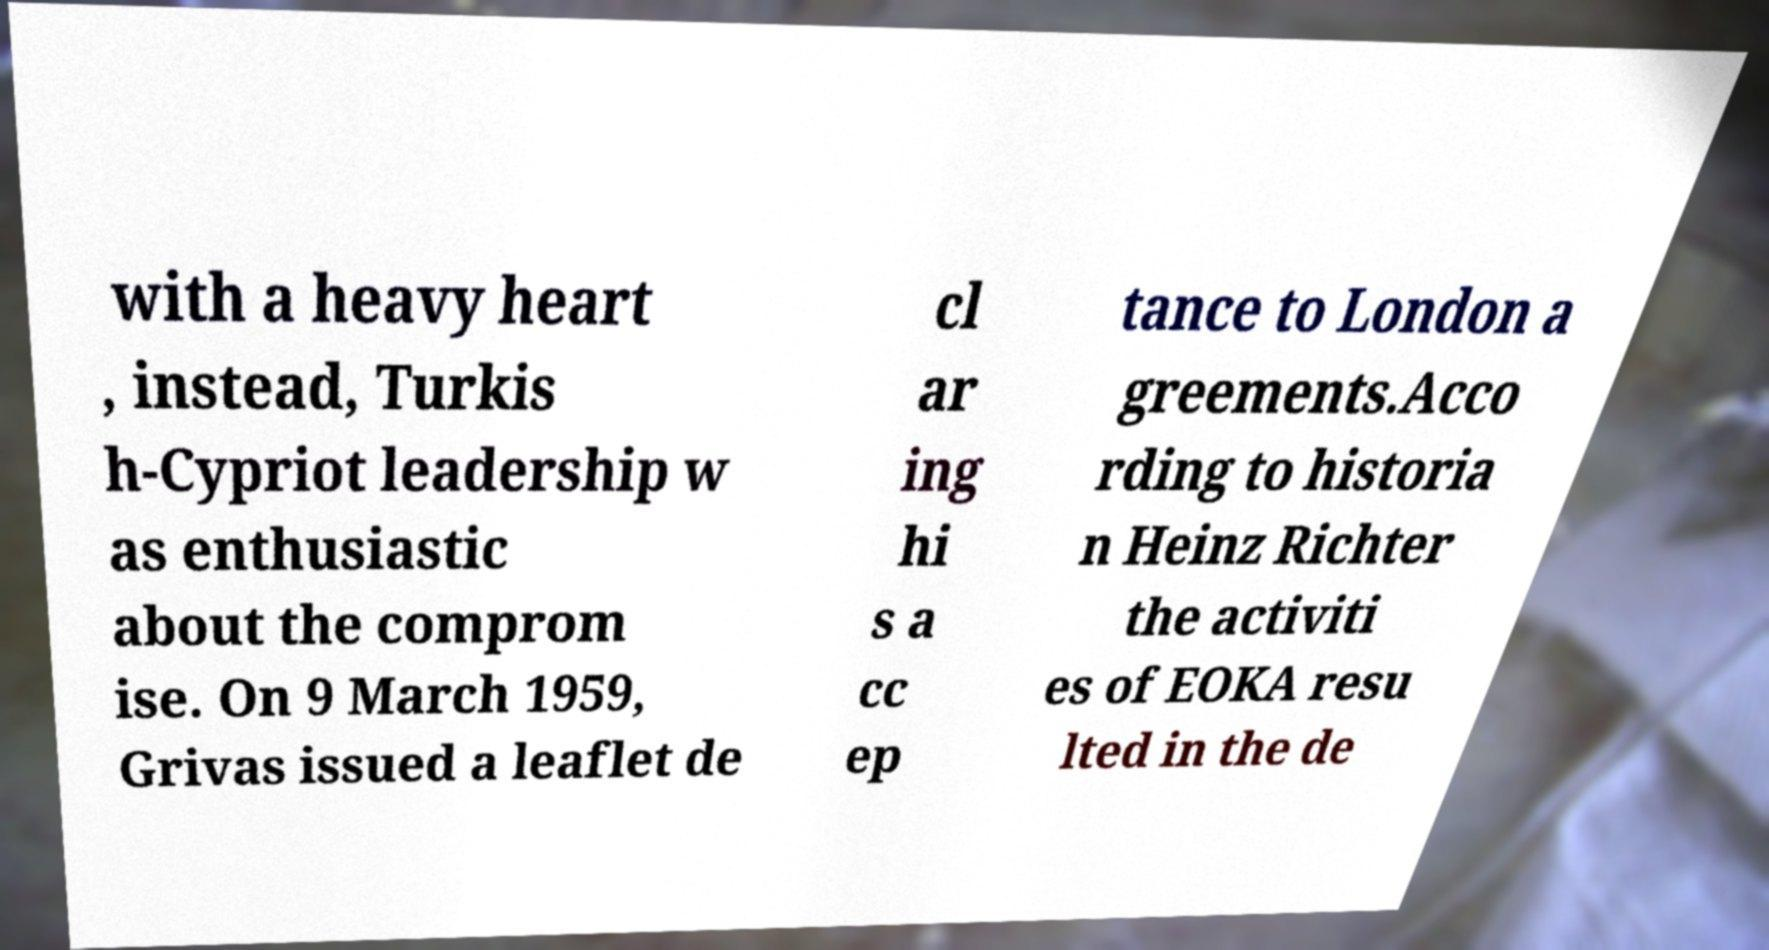There's text embedded in this image that I need extracted. Can you transcribe it verbatim? with a heavy heart , instead, Turkis h-Cypriot leadership w as enthusiastic about the comprom ise. On 9 March 1959, Grivas issued a leaflet de cl ar ing hi s a cc ep tance to London a greements.Acco rding to historia n Heinz Richter the activiti es of EOKA resu lted in the de 